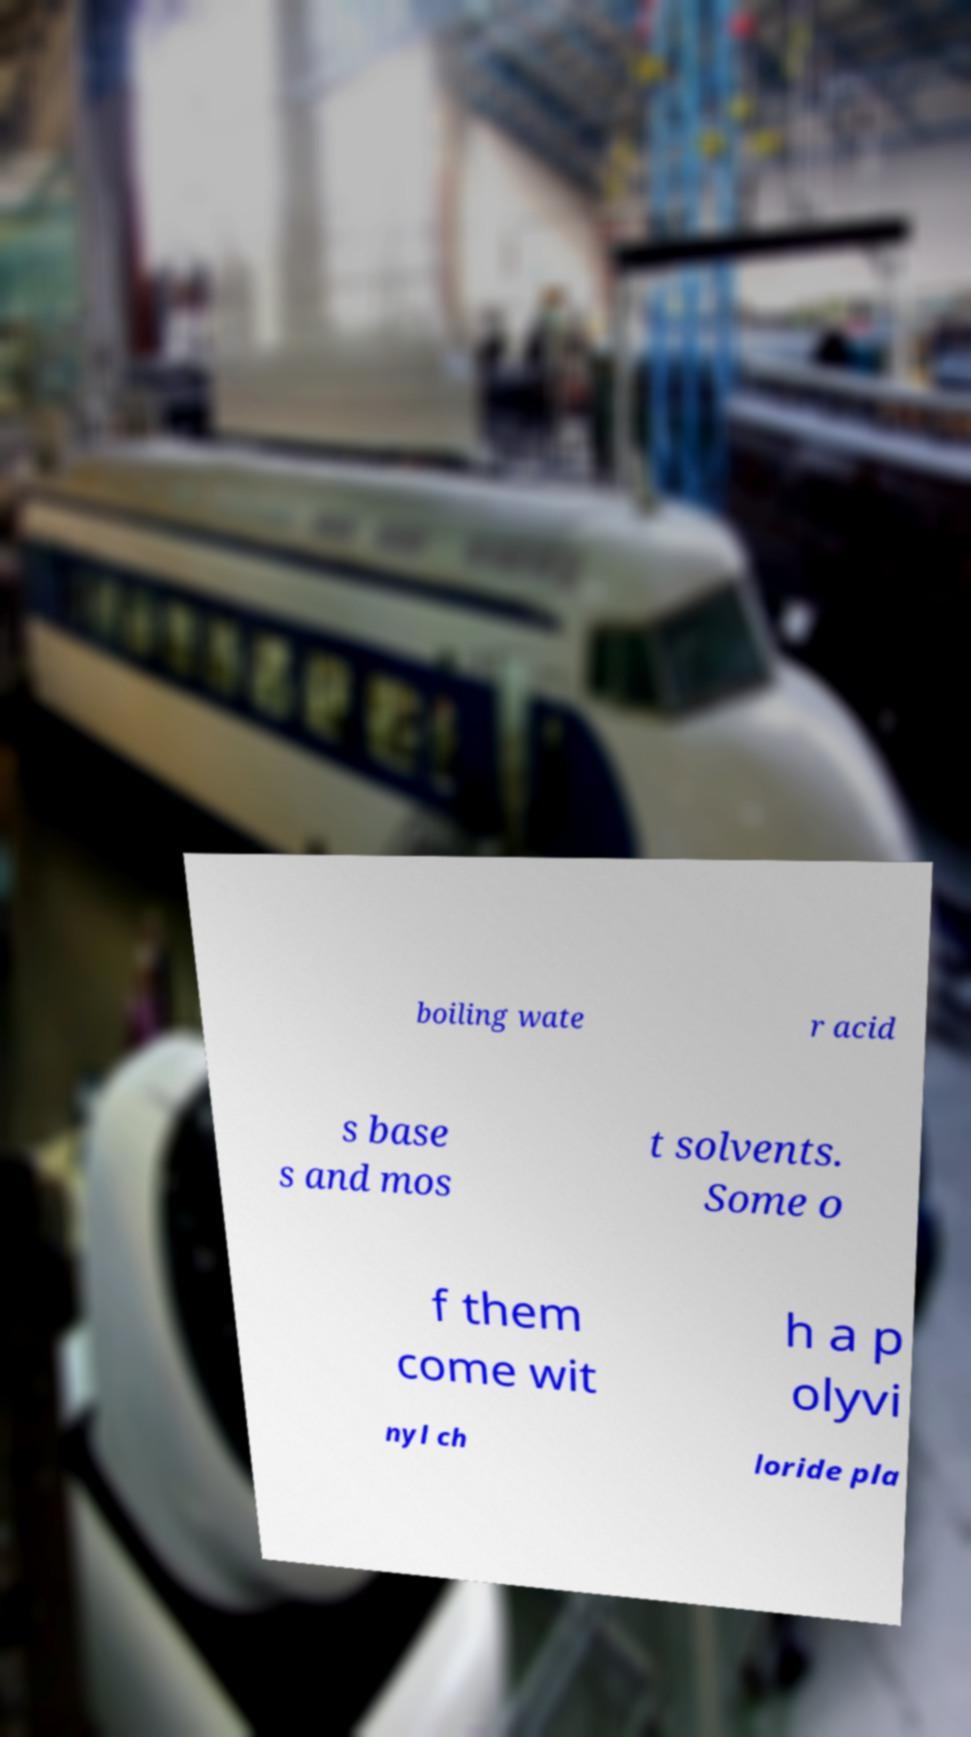What messages or text are displayed in this image? I need them in a readable, typed format. boiling wate r acid s base s and mos t solvents. Some o f them come wit h a p olyvi nyl ch loride pla 